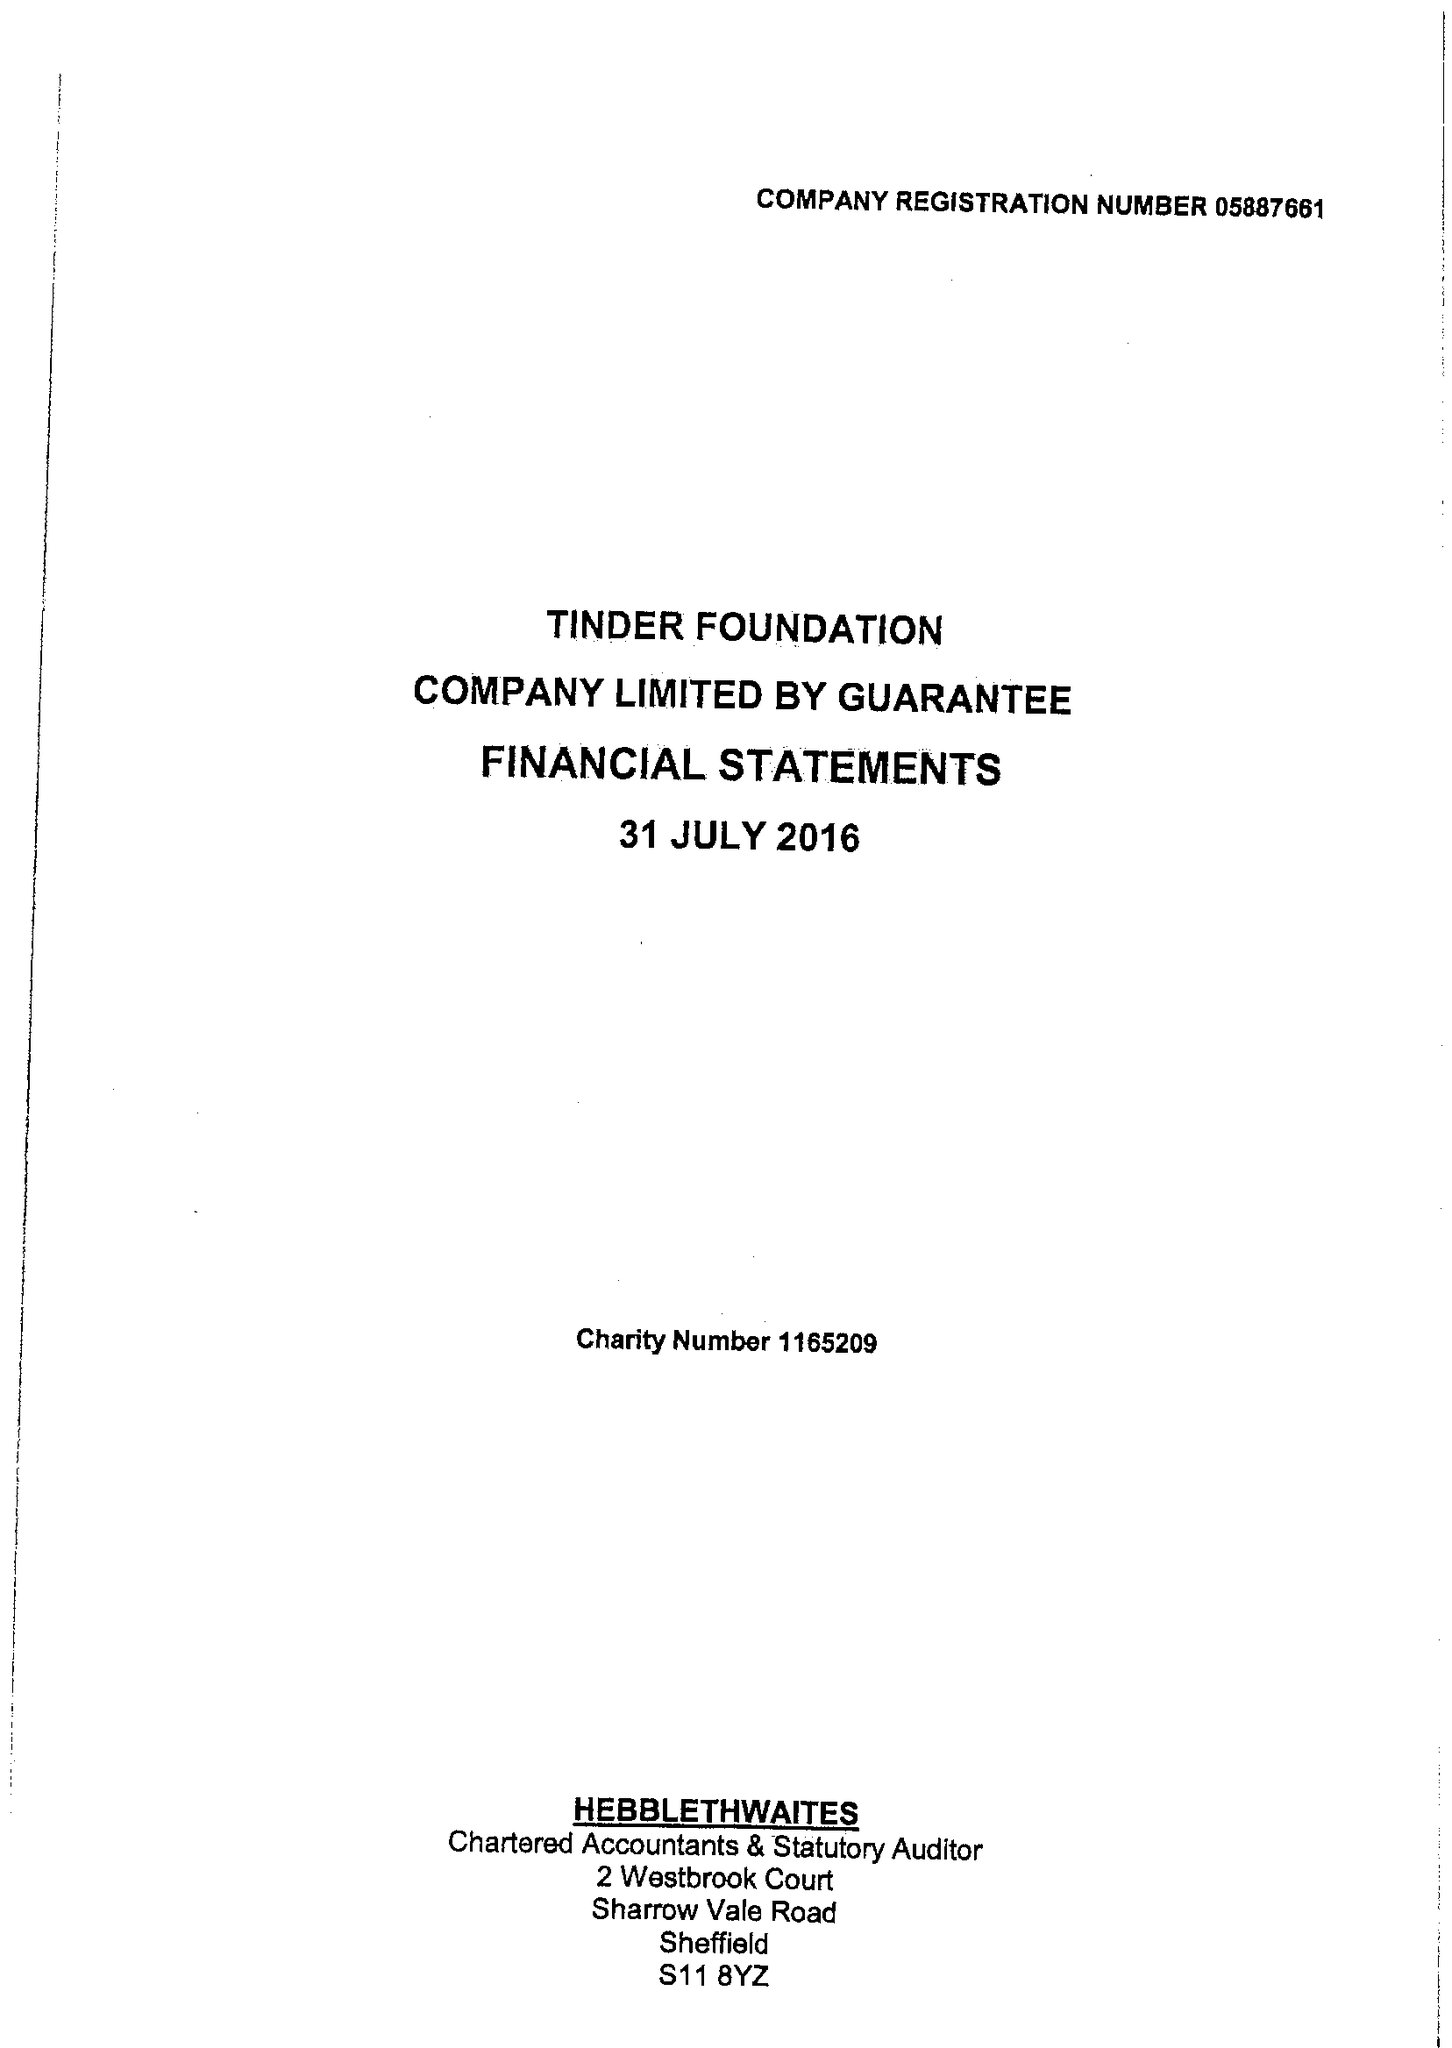What is the value for the charity_name?
Answer the question using a single word or phrase. Good Things Foundation 